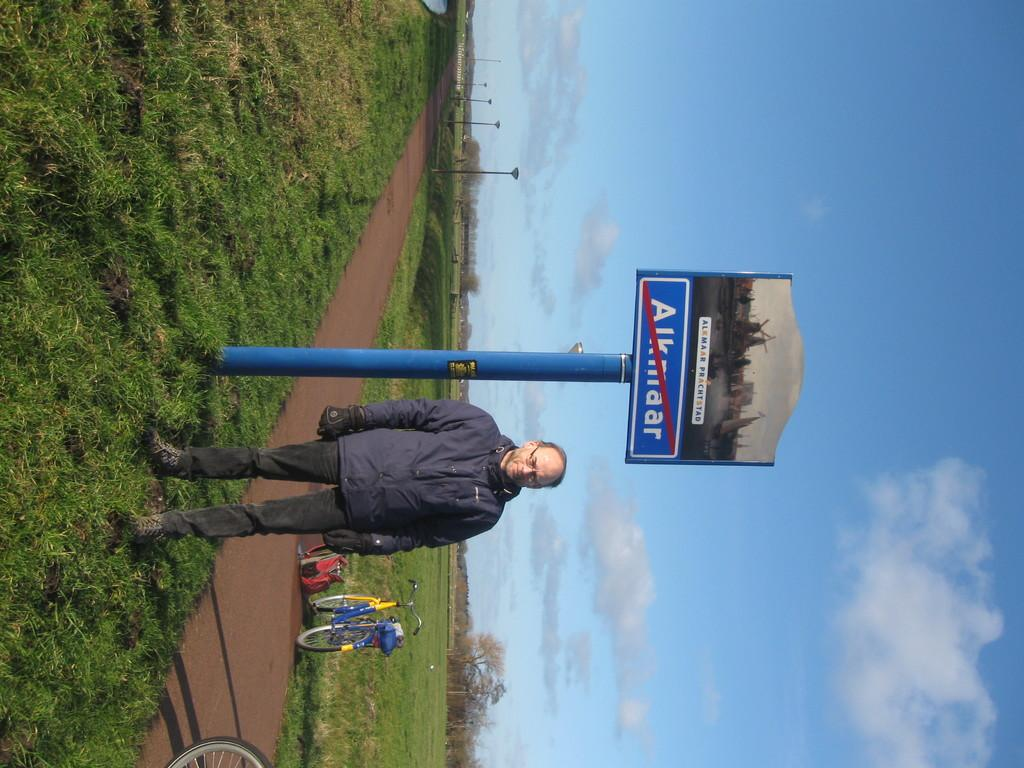What is the main subject in the image? There is a person standing in the image. What can be seen in the background of the image? There is a path and grass on the ground in the image. What objects are present in the image? There are bicycles and poles in the image. What is visible in the sky at the top of the image? There are clouds visible in the sky at the top of the image. How many passengers are on the bicycles in the image? There are no passengers on the bicycles in the image; they are not being ridden. What type of flock can be seen flying in the sky in the image? There are no birds or flocks visible in the sky in the image. 